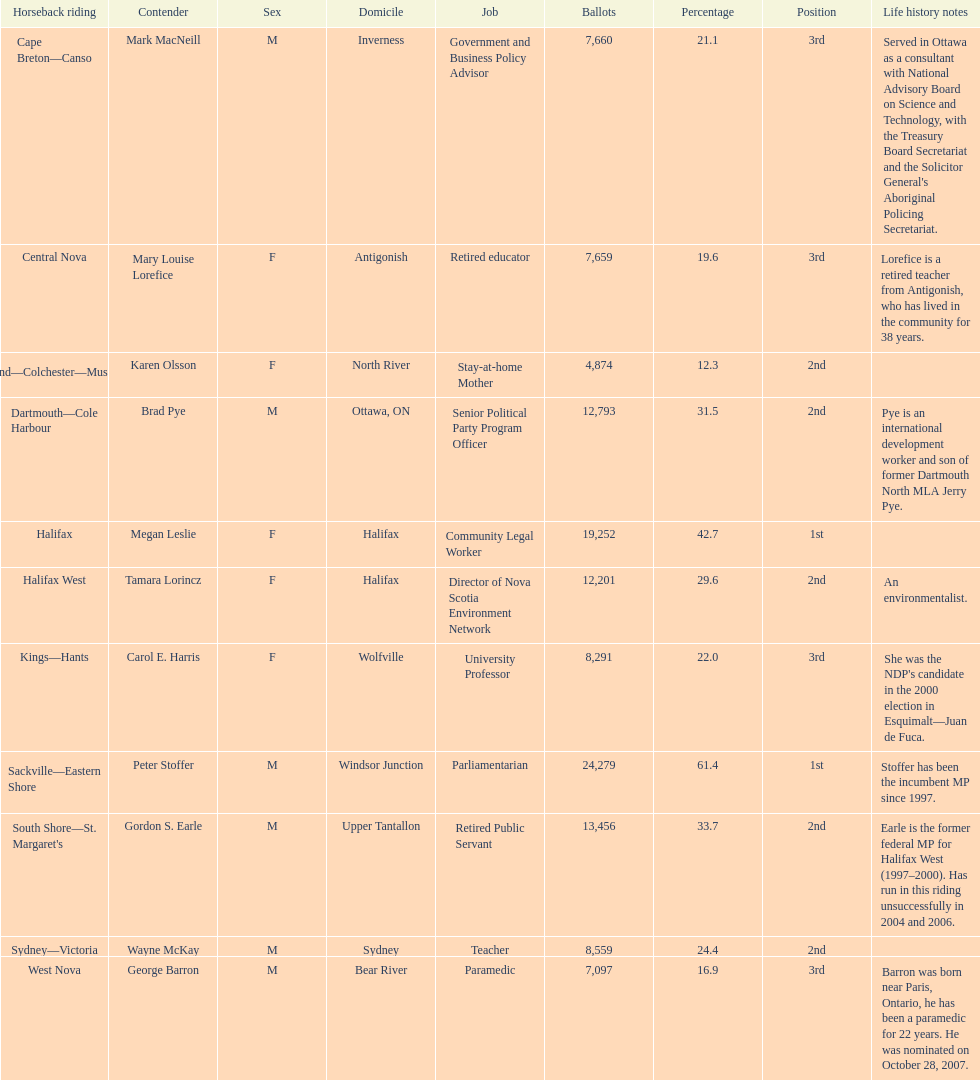Parse the full table. {'header': ['Horseback riding', 'Contender', 'Sex', 'Domicile', 'Job', 'Ballots', 'Percentage', 'Position', 'Life history notes'], 'rows': [['Cape Breton—Canso', 'Mark MacNeill', 'M', 'Inverness', 'Government and Business Policy Advisor', '7,660', '21.1', '3rd', "Served in Ottawa as a consultant with National Advisory Board on Science and Technology, with the Treasury Board Secretariat and the Solicitor General's Aboriginal Policing Secretariat."], ['Central Nova', 'Mary Louise Lorefice', 'F', 'Antigonish', 'Retired educator', '7,659', '19.6', '3rd', 'Lorefice is a retired teacher from Antigonish, who has lived in the community for 38 years.'], ['Cumberland—Colchester—Musquodoboit Valley', 'Karen Olsson', 'F', 'North River', 'Stay-at-home Mother', '4,874', '12.3', '2nd', ''], ['Dartmouth—Cole Harbour', 'Brad Pye', 'M', 'Ottawa, ON', 'Senior Political Party Program Officer', '12,793', '31.5', '2nd', 'Pye is an international development worker and son of former Dartmouth North MLA Jerry Pye.'], ['Halifax', 'Megan Leslie', 'F', 'Halifax', 'Community Legal Worker', '19,252', '42.7', '1st', ''], ['Halifax West', 'Tamara Lorincz', 'F', 'Halifax', 'Director of Nova Scotia Environment Network', '12,201', '29.6', '2nd', 'An environmentalist.'], ['Kings—Hants', 'Carol E. Harris', 'F', 'Wolfville', 'University Professor', '8,291', '22.0', '3rd', "She was the NDP's candidate in the 2000 election in Esquimalt—Juan de Fuca."], ['Sackville—Eastern Shore', 'Peter Stoffer', 'M', 'Windsor Junction', 'Parliamentarian', '24,279', '61.4', '1st', 'Stoffer has been the incumbent MP since 1997.'], ["South Shore—St. Margaret's", 'Gordon S. Earle', 'M', 'Upper Tantallon', 'Retired Public Servant', '13,456', '33.7', '2nd', 'Earle is the former federal MP for Halifax West (1997–2000). Has run in this riding unsuccessfully in 2004 and 2006.'], ['Sydney—Victoria', 'Wayne McKay', 'M', 'Sydney', 'Teacher', '8,559', '24.4', '2nd', ''], ['West Nova', 'George Barron', 'M', 'Bear River', 'Paramedic', '7,097', '16.9', '3rd', 'Barron was born near Paris, Ontario, he has been a paramedic for 22 years. He was nominated on October 28, 2007.']]} What is the total number of candidates? 11. 